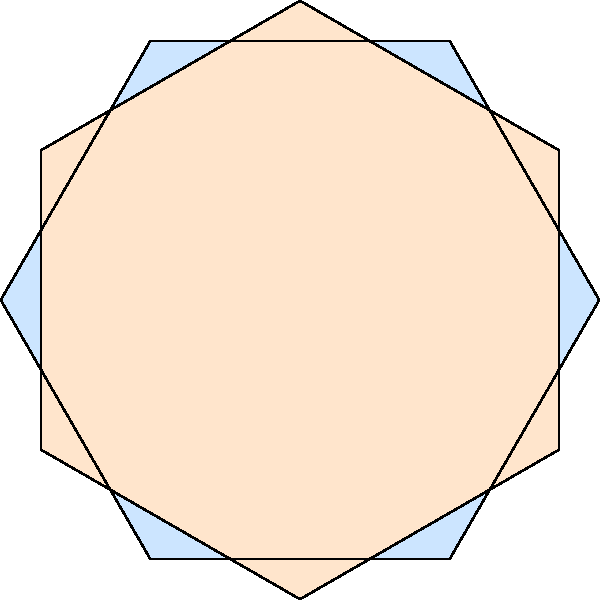In this mosaic artwork inspired by Islamic geometric patterns, what is the minimum number of regular hexagons needed to create the complete tessellation pattern shown? To determine the minimum number of regular hexagons needed for this tessellation pattern, let's analyze the structure step-by-step:

1. The pattern consists of two types of hexagons:
   a) Blue hexagons aligned vertically
   b) Orange hexagons rotated 30 degrees from the blue ones

2. Each hexagon in the pattern is divided into 6 equal triangular sections.

3. The central point where all hexagons meet forms a 12-pointed star.

4. To create this 12-pointed star, we need:
   - 6 triangular sections from blue hexagons
   - 6 triangular sections from orange hexagons

5. Since each hexagon contributes 6 triangular sections, we can calculate:
   - Number of blue hexagons = 6 ÷ 6 = 1
   - Number of orange hexagons = 6 ÷ 6 = 1

6. Therefore, the minimum number of hexagons needed is:
   1 (blue) + 1 (orange) = 2 hexagons

This tessellation pattern can be infinitely repeated using these two hexagons as the basic unit.
Answer: 2 hexagons 